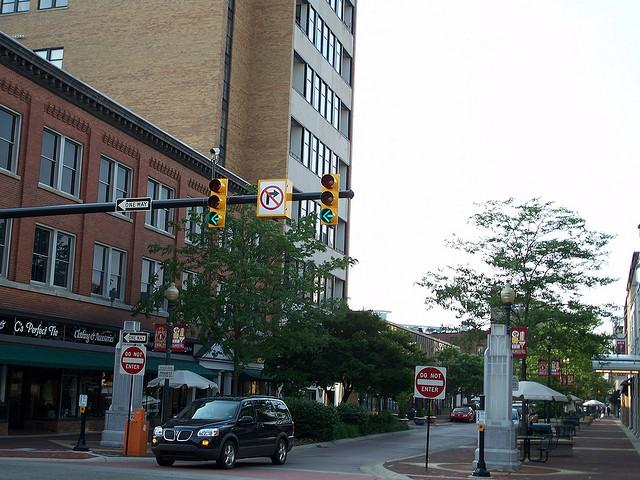Driving straight ahead might cause what? Please explain your reasoning. accident. There is a one way street. 